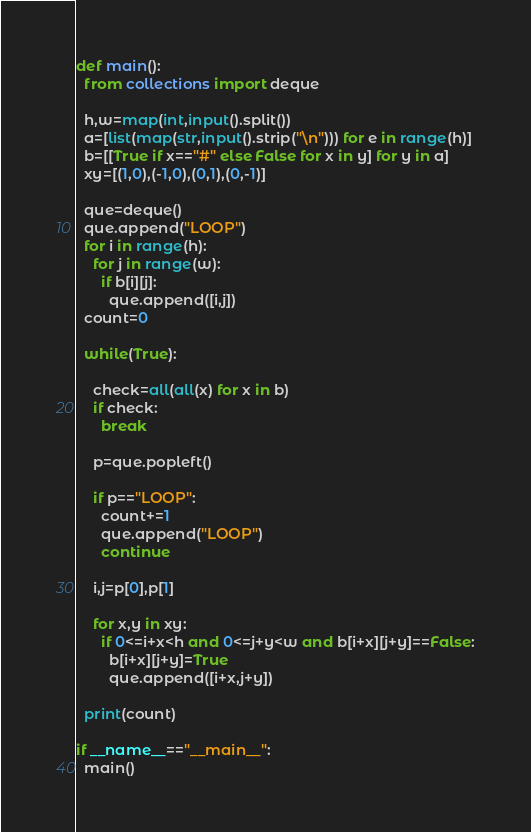<code> <loc_0><loc_0><loc_500><loc_500><_Python_>def main():
  from collections import deque
  
  h,w=map(int,input().split())
  a=[list(map(str,input().strip("\n"))) for e in range(h)]
  b=[[True if x=="#" else False for x in y] for y in a]
  xy=[(1,0),(-1,0),(0,1),(0,-1)]
  
  que=deque()
  que.append("LOOP")
  for i in range(h):
    for j in range(w):
      if b[i][j]:
        que.append([i,j])
  count=0

  while(True):
    
    check=all(all(x) for x in b)
    if check:
      break
    
    p=que.popleft()
    
    if p=="LOOP":
      count+=1
      que.append("LOOP")
      continue
    
    i,j=p[0],p[1]
    
    for x,y in xy:
      if 0<=i+x<h and 0<=j+y<w and b[i+x][j+y]==False:
        b[i+x][j+y]=True
        que.append([i+x,j+y])
    
  print(count)
  
if __name__=="__main__":
  main()</code> 